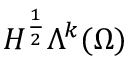<formula> <loc_0><loc_0><loc_500><loc_500>H ^ { \frac { 1 } { 2 } } \Lambda ^ { k } ( \Omega )</formula> 